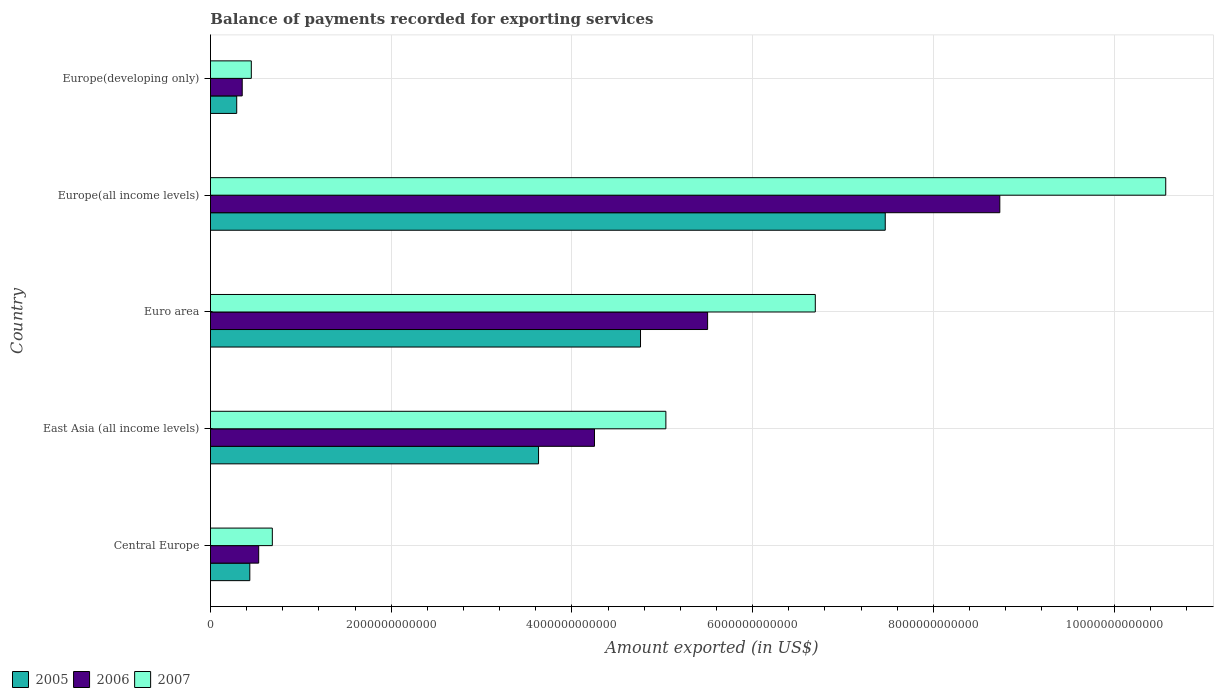How many bars are there on the 5th tick from the top?
Keep it short and to the point. 3. How many bars are there on the 2nd tick from the bottom?
Make the answer very short. 3. What is the label of the 4th group of bars from the top?
Offer a terse response. East Asia (all income levels). In how many cases, is the number of bars for a given country not equal to the number of legend labels?
Your answer should be very brief. 0. What is the amount exported in 2006 in Europe(all income levels)?
Make the answer very short. 8.74e+12. Across all countries, what is the maximum amount exported in 2005?
Make the answer very short. 7.47e+12. Across all countries, what is the minimum amount exported in 2006?
Ensure brevity in your answer.  3.51e+11. In which country was the amount exported in 2005 maximum?
Your answer should be compact. Europe(all income levels). In which country was the amount exported in 2007 minimum?
Provide a short and direct response. Europe(developing only). What is the total amount exported in 2006 in the graph?
Your answer should be compact. 1.94e+13. What is the difference between the amount exported in 2006 in East Asia (all income levels) and that in Europe(developing only)?
Offer a terse response. 3.90e+12. What is the difference between the amount exported in 2007 in Europe(all income levels) and the amount exported in 2006 in Central Europe?
Provide a short and direct response. 1.00e+13. What is the average amount exported in 2005 per country?
Make the answer very short. 3.32e+12. What is the difference between the amount exported in 2006 and amount exported in 2005 in Europe(developing only)?
Provide a short and direct response. 6.08e+1. In how many countries, is the amount exported in 2005 greater than 7600000000000 US$?
Give a very brief answer. 0. What is the ratio of the amount exported in 2005 in East Asia (all income levels) to that in Europe(developing only)?
Give a very brief answer. 12.5. Is the amount exported in 2005 in Europe(all income levels) less than that in Europe(developing only)?
Provide a succinct answer. No. What is the difference between the highest and the second highest amount exported in 2006?
Keep it short and to the point. 3.23e+12. What is the difference between the highest and the lowest amount exported in 2005?
Make the answer very short. 7.18e+12. In how many countries, is the amount exported in 2006 greater than the average amount exported in 2006 taken over all countries?
Provide a succinct answer. 3. Is the sum of the amount exported in 2007 in East Asia (all income levels) and Euro area greater than the maximum amount exported in 2005 across all countries?
Make the answer very short. Yes. What does the 3rd bar from the bottom in East Asia (all income levels) represents?
Give a very brief answer. 2007. How many bars are there?
Your answer should be very brief. 15. Are all the bars in the graph horizontal?
Give a very brief answer. Yes. What is the difference between two consecutive major ticks on the X-axis?
Ensure brevity in your answer.  2.00e+12. Are the values on the major ticks of X-axis written in scientific E-notation?
Your answer should be very brief. No. Where does the legend appear in the graph?
Make the answer very short. Bottom left. What is the title of the graph?
Offer a terse response. Balance of payments recorded for exporting services. Does "1983" appear as one of the legend labels in the graph?
Your answer should be very brief. No. What is the label or title of the X-axis?
Ensure brevity in your answer.  Amount exported (in US$). What is the label or title of the Y-axis?
Your response must be concise. Country. What is the Amount exported (in US$) of 2005 in Central Europe?
Make the answer very short. 4.35e+11. What is the Amount exported (in US$) in 2006 in Central Europe?
Give a very brief answer. 5.34e+11. What is the Amount exported (in US$) of 2007 in Central Europe?
Offer a terse response. 6.84e+11. What is the Amount exported (in US$) of 2005 in East Asia (all income levels)?
Your response must be concise. 3.63e+12. What is the Amount exported (in US$) of 2006 in East Asia (all income levels)?
Keep it short and to the point. 4.25e+12. What is the Amount exported (in US$) in 2007 in East Asia (all income levels)?
Give a very brief answer. 5.04e+12. What is the Amount exported (in US$) of 2005 in Euro area?
Give a very brief answer. 4.76e+12. What is the Amount exported (in US$) of 2006 in Euro area?
Keep it short and to the point. 5.50e+12. What is the Amount exported (in US$) of 2007 in Euro area?
Your answer should be very brief. 6.69e+12. What is the Amount exported (in US$) in 2005 in Europe(all income levels)?
Your answer should be very brief. 7.47e+12. What is the Amount exported (in US$) in 2006 in Europe(all income levels)?
Provide a short and direct response. 8.74e+12. What is the Amount exported (in US$) of 2007 in Europe(all income levels)?
Keep it short and to the point. 1.06e+13. What is the Amount exported (in US$) in 2005 in Europe(developing only)?
Provide a short and direct response. 2.91e+11. What is the Amount exported (in US$) in 2006 in Europe(developing only)?
Your answer should be very brief. 3.51e+11. What is the Amount exported (in US$) in 2007 in Europe(developing only)?
Make the answer very short. 4.52e+11. Across all countries, what is the maximum Amount exported (in US$) of 2005?
Offer a very short reply. 7.47e+12. Across all countries, what is the maximum Amount exported (in US$) in 2006?
Your answer should be very brief. 8.74e+12. Across all countries, what is the maximum Amount exported (in US$) of 2007?
Offer a very short reply. 1.06e+13. Across all countries, what is the minimum Amount exported (in US$) in 2005?
Make the answer very short. 2.91e+11. Across all countries, what is the minimum Amount exported (in US$) in 2006?
Make the answer very short. 3.51e+11. Across all countries, what is the minimum Amount exported (in US$) of 2007?
Your response must be concise. 4.52e+11. What is the total Amount exported (in US$) of 2005 in the graph?
Your response must be concise. 1.66e+13. What is the total Amount exported (in US$) in 2006 in the graph?
Offer a very short reply. 1.94e+13. What is the total Amount exported (in US$) of 2007 in the graph?
Your answer should be compact. 2.34e+13. What is the difference between the Amount exported (in US$) in 2005 in Central Europe and that in East Asia (all income levels)?
Your answer should be compact. -3.20e+12. What is the difference between the Amount exported (in US$) of 2006 in Central Europe and that in East Asia (all income levels)?
Provide a short and direct response. -3.72e+12. What is the difference between the Amount exported (in US$) of 2007 in Central Europe and that in East Asia (all income levels)?
Make the answer very short. -4.36e+12. What is the difference between the Amount exported (in US$) in 2005 in Central Europe and that in Euro area?
Ensure brevity in your answer.  -4.32e+12. What is the difference between the Amount exported (in US$) of 2006 in Central Europe and that in Euro area?
Ensure brevity in your answer.  -4.97e+12. What is the difference between the Amount exported (in US$) in 2007 in Central Europe and that in Euro area?
Ensure brevity in your answer.  -6.01e+12. What is the difference between the Amount exported (in US$) in 2005 in Central Europe and that in Europe(all income levels)?
Make the answer very short. -7.03e+12. What is the difference between the Amount exported (in US$) of 2006 in Central Europe and that in Europe(all income levels)?
Offer a terse response. -8.20e+12. What is the difference between the Amount exported (in US$) of 2007 in Central Europe and that in Europe(all income levels)?
Your answer should be compact. -9.89e+12. What is the difference between the Amount exported (in US$) in 2005 in Central Europe and that in Europe(developing only)?
Ensure brevity in your answer.  1.45e+11. What is the difference between the Amount exported (in US$) of 2006 in Central Europe and that in Europe(developing only)?
Provide a short and direct response. 1.82e+11. What is the difference between the Amount exported (in US$) of 2007 in Central Europe and that in Europe(developing only)?
Offer a very short reply. 2.32e+11. What is the difference between the Amount exported (in US$) in 2005 in East Asia (all income levels) and that in Euro area?
Provide a succinct answer. -1.13e+12. What is the difference between the Amount exported (in US$) in 2006 in East Asia (all income levels) and that in Euro area?
Your response must be concise. -1.25e+12. What is the difference between the Amount exported (in US$) of 2007 in East Asia (all income levels) and that in Euro area?
Ensure brevity in your answer.  -1.65e+12. What is the difference between the Amount exported (in US$) of 2005 in East Asia (all income levels) and that in Europe(all income levels)?
Make the answer very short. -3.84e+12. What is the difference between the Amount exported (in US$) of 2006 in East Asia (all income levels) and that in Europe(all income levels)?
Your answer should be compact. -4.49e+12. What is the difference between the Amount exported (in US$) of 2007 in East Asia (all income levels) and that in Europe(all income levels)?
Offer a terse response. -5.53e+12. What is the difference between the Amount exported (in US$) in 2005 in East Asia (all income levels) and that in Europe(developing only)?
Provide a short and direct response. 3.34e+12. What is the difference between the Amount exported (in US$) in 2006 in East Asia (all income levels) and that in Europe(developing only)?
Keep it short and to the point. 3.90e+12. What is the difference between the Amount exported (in US$) in 2007 in East Asia (all income levels) and that in Europe(developing only)?
Your answer should be compact. 4.59e+12. What is the difference between the Amount exported (in US$) in 2005 in Euro area and that in Europe(all income levels)?
Ensure brevity in your answer.  -2.71e+12. What is the difference between the Amount exported (in US$) in 2006 in Euro area and that in Europe(all income levels)?
Keep it short and to the point. -3.23e+12. What is the difference between the Amount exported (in US$) of 2007 in Euro area and that in Europe(all income levels)?
Your answer should be very brief. -3.88e+12. What is the difference between the Amount exported (in US$) of 2005 in Euro area and that in Europe(developing only)?
Ensure brevity in your answer.  4.47e+12. What is the difference between the Amount exported (in US$) in 2006 in Euro area and that in Europe(developing only)?
Ensure brevity in your answer.  5.15e+12. What is the difference between the Amount exported (in US$) in 2007 in Euro area and that in Europe(developing only)?
Your answer should be compact. 6.24e+12. What is the difference between the Amount exported (in US$) in 2005 in Europe(all income levels) and that in Europe(developing only)?
Provide a succinct answer. 7.18e+12. What is the difference between the Amount exported (in US$) in 2006 in Europe(all income levels) and that in Europe(developing only)?
Provide a short and direct response. 8.38e+12. What is the difference between the Amount exported (in US$) of 2007 in Europe(all income levels) and that in Europe(developing only)?
Your answer should be compact. 1.01e+13. What is the difference between the Amount exported (in US$) of 2005 in Central Europe and the Amount exported (in US$) of 2006 in East Asia (all income levels)?
Offer a terse response. -3.81e+12. What is the difference between the Amount exported (in US$) of 2005 in Central Europe and the Amount exported (in US$) of 2007 in East Asia (all income levels)?
Your response must be concise. -4.60e+12. What is the difference between the Amount exported (in US$) in 2006 in Central Europe and the Amount exported (in US$) in 2007 in East Asia (all income levels)?
Make the answer very short. -4.51e+12. What is the difference between the Amount exported (in US$) of 2005 in Central Europe and the Amount exported (in US$) of 2006 in Euro area?
Your answer should be very brief. -5.07e+12. What is the difference between the Amount exported (in US$) in 2005 in Central Europe and the Amount exported (in US$) in 2007 in Euro area?
Offer a terse response. -6.26e+12. What is the difference between the Amount exported (in US$) in 2006 in Central Europe and the Amount exported (in US$) in 2007 in Euro area?
Offer a very short reply. -6.16e+12. What is the difference between the Amount exported (in US$) of 2005 in Central Europe and the Amount exported (in US$) of 2006 in Europe(all income levels)?
Your response must be concise. -8.30e+12. What is the difference between the Amount exported (in US$) in 2005 in Central Europe and the Amount exported (in US$) in 2007 in Europe(all income levels)?
Provide a succinct answer. -1.01e+13. What is the difference between the Amount exported (in US$) in 2006 in Central Europe and the Amount exported (in US$) in 2007 in Europe(all income levels)?
Provide a succinct answer. -1.00e+13. What is the difference between the Amount exported (in US$) in 2005 in Central Europe and the Amount exported (in US$) in 2006 in Europe(developing only)?
Keep it short and to the point. 8.40e+1. What is the difference between the Amount exported (in US$) of 2005 in Central Europe and the Amount exported (in US$) of 2007 in Europe(developing only)?
Your answer should be very brief. -1.67e+1. What is the difference between the Amount exported (in US$) of 2006 in Central Europe and the Amount exported (in US$) of 2007 in Europe(developing only)?
Your response must be concise. 8.15e+1. What is the difference between the Amount exported (in US$) in 2005 in East Asia (all income levels) and the Amount exported (in US$) in 2006 in Euro area?
Offer a very short reply. -1.87e+12. What is the difference between the Amount exported (in US$) in 2005 in East Asia (all income levels) and the Amount exported (in US$) in 2007 in Euro area?
Provide a succinct answer. -3.06e+12. What is the difference between the Amount exported (in US$) in 2006 in East Asia (all income levels) and the Amount exported (in US$) in 2007 in Euro area?
Offer a terse response. -2.44e+12. What is the difference between the Amount exported (in US$) of 2005 in East Asia (all income levels) and the Amount exported (in US$) of 2006 in Europe(all income levels)?
Your answer should be very brief. -5.10e+12. What is the difference between the Amount exported (in US$) in 2005 in East Asia (all income levels) and the Amount exported (in US$) in 2007 in Europe(all income levels)?
Offer a terse response. -6.94e+12. What is the difference between the Amount exported (in US$) in 2006 in East Asia (all income levels) and the Amount exported (in US$) in 2007 in Europe(all income levels)?
Your answer should be very brief. -6.32e+12. What is the difference between the Amount exported (in US$) in 2005 in East Asia (all income levels) and the Amount exported (in US$) in 2006 in Europe(developing only)?
Give a very brief answer. 3.28e+12. What is the difference between the Amount exported (in US$) in 2005 in East Asia (all income levels) and the Amount exported (in US$) in 2007 in Europe(developing only)?
Your answer should be very brief. 3.18e+12. What is the difference between the Amount exported (in US$) in 2006 in East Asia (all income levels) and the Amount exported (in US$) in 2007 in Europe(developing only)?
Make the answer very short. 3.80e+12. What is the difference between the Amount exported (in US$) of 2005 in Euro area and the Amount exported (in US$) of 2006 in Europe(all income levels)?
Offer a very short reply. -3.98e+12. What is the difference between the Amount exported (in US$) in 2005 in Euro area and the Amount exported (in US$) in 2007 in Europe(all income levels)?
Offer a terse response. -5.81e+12. What is the difference between the Amount exported (in US$) in 2006 in Euro area and the Amount exported (in US$) in 2007 in Europe(all income levels)?
Provide a short and direct response. -5.07e+12. What is the difference between the Amount exported (in US$) in 2005 in Euro area and the Amount exported (in US$) in 2006 in Europe(developing only)?
Offer a very short reply. 4.41e+12. What is the difference between the Amount exported (in US$) in 2005 in Euro area and the Amount exported (in US$) in 2007 in Europe(developing only)?
Offer a terse response. 4.31e+12. What is the difference between the Amount exported (in US$) in 2006 in Euro area and the Amount exported (in US$) in 2007 in Europe(developing only)?
Provide a succinct answer. 5.05e+12. What is the difference between the Amount exported (in US$) of 2005 in Europe(all income levels) and the Amount exported (in US$) of 2006 in Europe(developing only)?
Give a very brief answer. 7.12e+12. What is the difference between the Amount exported (in US$) in 2005 in Europe(all income levels) and the Amount exported (in US$) in 2007 in Europe(developing only)?
Your answer should be compact. 7.02e+12. What is the difference between the Amount exported (in US$) in 2006 in Europe(all income levels) and the Amount exported (in US$) in 2007 in Europe(developing only)?
Give a very brief answer. 8.28e+12. What is the average Amount exported (in US$) in 2005 per country?
Ensure brevity in your answer.  3.32e+12. What is the average Amount exported (in US$) of 2006 per country?
Offer a terse response. 3.87e+12. What is the average Amount exported (in US$) of 2007 per country?
Provide a succinct answer. 4.69e+12. What is the difference between the Amount exported (in US$) of 2005 and Amount exported (in US$) of 2006 in Central Europe?
Offer a very short reply. -9.82e+1. What is the difference between the Amount exported (in US$) in 2005 and Amount exported (in US$) in 2007 in Central Europe?
Your answer should be very brief. -2.49e+11. What is the difference between the Amount exported (in US$) in 2006 and Amount exported (in US$) in 2007 in Central Europe?
Give a very brief answer. -1.51e+11. What is the difference between the Amount exported (in US$) of 2005 and Amount exported (in US$) of 2006 in East Asia (all income levels)?
Offer a terse response. -6.19e+11. What is the difference between the Amount exported (in US$) of 2005 and Amount exported (in US$) of 2007 in East Asia (all income levels)?
Your answer should be compact. -1.41e+12. What is the difference between the Amount exported (in US$) of 2006 and Amount exported (in US$) of 2007 in East Asia (all income levels)?
Make the answer very short. -7.90e+11. What is the difference between the Amount exported (in US$) in 2005 and Amount exported (in US$) in 2006 in Euro area?
Your answer should be compact. -7.42e+11. What is the difference between the Amount exported (in US$) of 2005 and Amount exported (in US$) of 2007 in Euro area?
Offer a very short reply. -1.93e+12. What is the difference between the Amount exported (in US$) in 2006 and Amount exported (in US$) in 2007 in Euro area?
Offer a very short reply. -1.19e+12. What is the difference between the Amount exported (in US$) in 2005 and Amount exported (in US$) in 2006 in Europe(all income levels)?
Offer a very short reply. -1.27e+12. What is the difference between the Amount exported (in US$) of 2005 and Amount exported (in US$) of 2007 in Europe(all income levels)?
Offer a very short reply. -3.10e+12. What is the difference between the Amount exported (in US$) in 2006 and Amount exported (in US$) in 2007 in Europe(all income levels)?
Your answer should be very brief. -1.84e+12. What is the difference between the Amount exported (in US$) in 2005 and Amount exported (in US$) in 2006 in Europe(developing only)?
Your response must be concise. -6.08e+1. What is the difference between the Amount exported (in US$) in 2005 and Amount exported (in US$) in 2007 in Europe(developing only)?
Your response must be concise. -1.61e+11. What is the difference between the Amount exported (in US$) of 2006 and Amount exported (in US$) of 2007 in Europe(developing only)?
Your response must be concise. -1.01e+11. What is the ratio of the Amount exported (in US$) in 2005 in Central Europe to that in East Asia (all income levels)?
Your answer should be very brief. 0.12. What is the ratio of the Amount exported (in US$) of 2006 in Central Europe to that in East Asia (all income levels)?
Make the answer very short. 0.13. What is the ratio of the Amount exported (in US$) of 2007 in Central Europe to that in East Asia (all income levels)?
Provide a succinct answer. 0.14. What is the ratio of the Amount exported (in US$) in 2005 in Central Europe to that in Euro area?
Keep it short and to the point. 0.09. What is the ratio of the Amount exported (in US$) in 2006 in Central Europe to that in Euro area?
Provide a succinct answer. 0.1. What is the ratio of the Amount exported (in US$) of 2007 in Central Europe to that in Euro area?
Make the answer very short. 0.1. What is the ratio of the Amount exported (in US$) in 2005 in Central Europe to that in Europe(all income levels)?
Your response must be concise. 0.06. What is the ratio of the Amount exported (in US$) in 2006 in Central Europe to that in Europe(all income levels)?
Your answer should be compact. 0.06. What is the ratio of the Amount exported (in US$) of 2007 in Central Europe to that in Europe(all income levels)?
Offer a terse response. 0.06. What is the ratio of the Amount exported (in US$) of 2005 in Central Europe to that in Europe(developing only)?
Your answer should be compact. 1.5. What is the ratio of the Amount exported (in US$) of 2006 in Central Europe to that in Europe(developing only)?
Your response must be concise. 1.52. What is the ratio of the Amount exported (in US$) in 2007 in Central Europe to that in Europe(developing only)?
Offer a very short reply. 1.51. What is the ratio of the Amount exported (in US$) of 2005 in East Asia (all income levels) to that in Euro area?
Keep it short and to the point. 0.76. What is the ratio of the Amount exported (in US$) of 2006 in East Asia (all income levels) to that in Euro area?
Your answer should be very brief. 0.77. What is the ratio of the Amount exported (in US$) of 2007 in East Asia (all income levels) to that in Euro area?
Give a very brief answer. 0.75. What is the ratio of the Amount exported (in US$) in 2005 in East Asia (all income levels) to that in Europe(all income levels)?
Keep it short and to the point. 0.49. What is the ratio of the Amount exported (in US$) of 2006 in East Asia (all income levels) to that in Europe(all income levels)?
Make the answer very short. 0.49. What is the ratio of the Amount exported (in US$) of 2007 in East Asia (all income levels) to that in Europe(all income levels)?
Keep it short and to the point. 0.48. What is the ratio of the Amount exported (in US$) in 2005 in East Asia (all income levels) to that in Europe(developing only)?
Offer a terse response. 12.5. What is the ratio of the Amount exported (in US$) in 2006 in East Asia (all income levels) to that in Europe(developing only)?
Your response must be concise. 12.09. What is the ratio of the Amount exported (in US$) of 2007 in East Asia (all income levels) to that in Europe(developing only)?
Offer a terse response. 11.15. What is the ratio of the Amount exported (in US$) in 2005 in Euro area to that in Europe(all income levels)?
Give a very brief answer. 0.64. What is the ratio of the Amount exported (in US$) in 2006 in Euro area to that in Europe(all income levels)?
Keep it short and to the point. 0.63. What is the ratio of the Amount exported (in US$) in 2007 in Euro area to that in Europe(all income levels)?
Offer a very short reply. 0.63. What is the ratio of the Amount exported (in US$) of 2005 in Euro area to that in Europe(developing only)?
Ensure brevity in your answer.  16.38. What is the ratio of the Amount exported (in US$) in 2006 in Euro area to that in Europe(developing only)?
Offer a very short reply. 15.66. What is the ratio of the Amount exported (in US$) in 2007 in Euro area to that in Europe(developing only)?
Provide a succinct answer. 14.81. What is the ratio of the Amount exported (in US$) of 2005 in Europe(all income levels) to that in Europe(developing only)?
Ensure brevity in your answer.  25.7. What is the ratio of the Amount exported (in US$) of 2006 in Europe(all income levels) to that in Europe(developing only)?
Keep it short and to the point. 24.86. What is the ratio of the Amount exported (in US$) of 2007 in Europe(all income levels) to that in Europe(developing only)?
Your answer should be compact. 23.39. What is the difference between the highest and the second highest Amount exported (in US$) in 2005?
Your answer should be very brief. 2.71e+12. What is the difference between the highest and the second highest Amount exported (in US$) in 2006?
Your response must be concise. 3.23e+12. What is the difference between the highest and the second highest Amount exported (in US$) in 2007?
Keep it short and to the point. 3.88e+12. What is the difference between the highest and the lowest Amount exported (in US$) in 2005?
Offer a very short reply. 7.18e+12. What is the difference between the highest and the lowest Amount exported (in US$) of 2006?
Provide a short and direct response. 8.38e+12. What is the difference between the highest and the lowest Amount exported (in US$) in 2007?
Your response must be concise. 1.01e+13. 